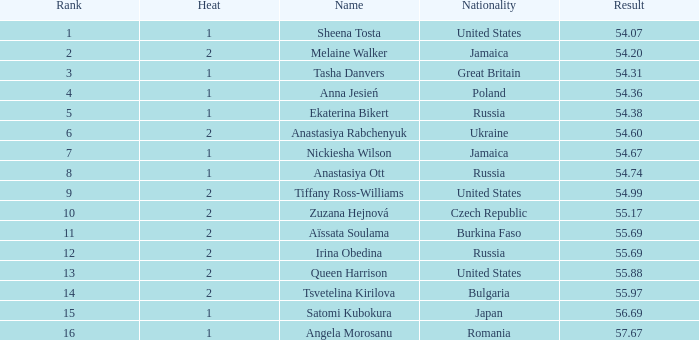97? None. 